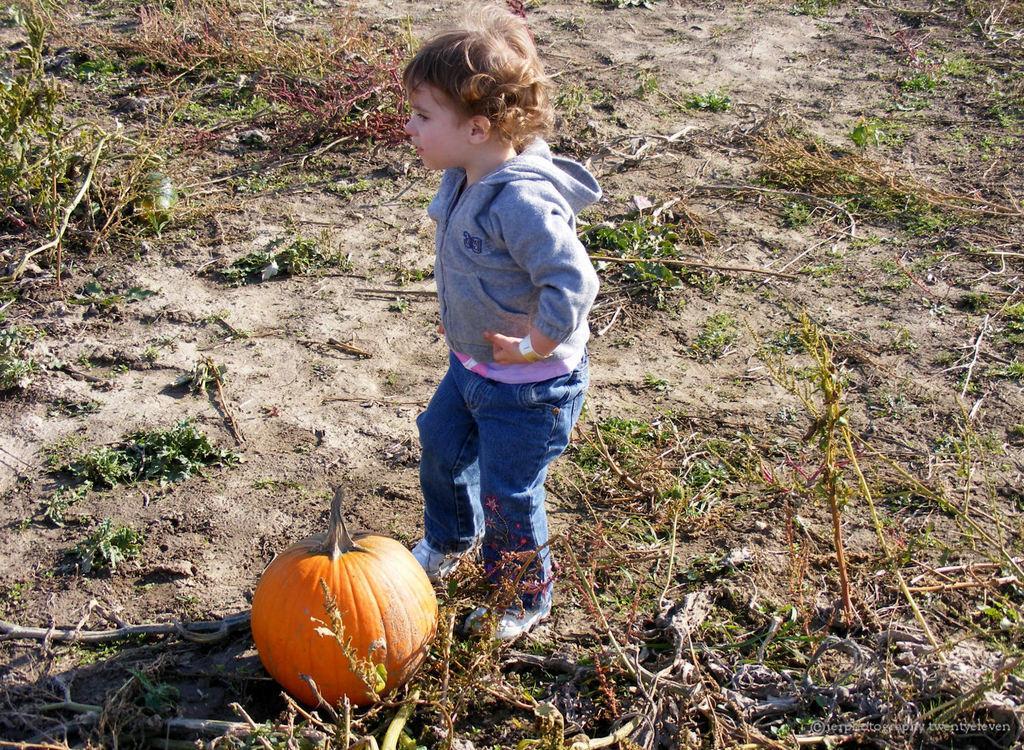Could you give a brief overview of what you see in this image? In the center of the image, we can see a kid wearing a coat and standing and at the bottom, there is a pumpkin and we can see some plants on the ground. 